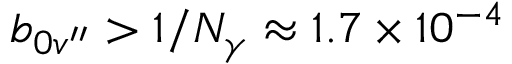<formula> <loc_0><loc_0><loc_500><loc_500>b _ { 0 v ^ { \prime \prime } } > 1 / N _ { \gamma } \approx 1 . 7 \times 1 0 ^ { - 4 }</formula> 